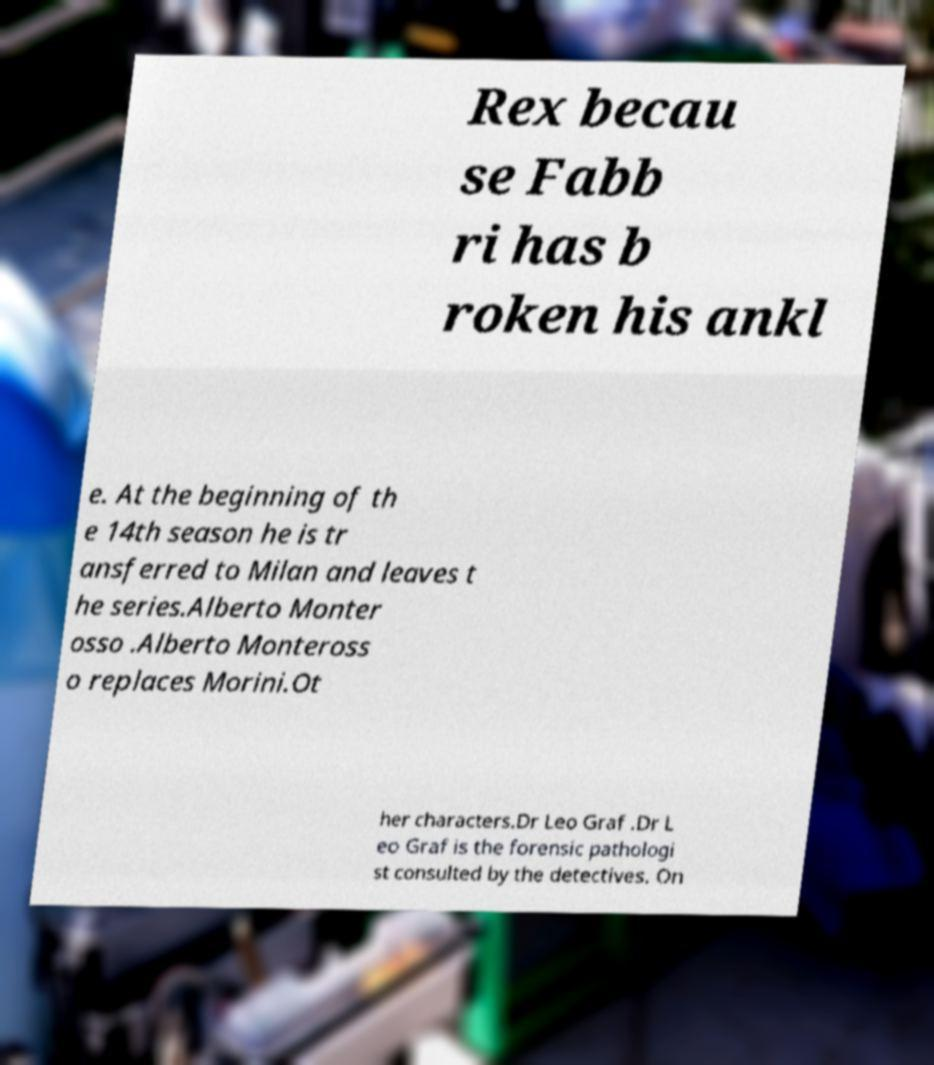Could you extract and type out the text from this image? Rex becau se Fabb ri has b roken his ankl e. At the beginning of th e 14th season he is tr ansferred to Milan and leaves t he series.Alberto Monter osso .Alberto Monteross o replaces Morini.Ot her characters.Dr Leo Graf .Dr L eo Graf is the forensic pathologi st consulted by the detectives. On 